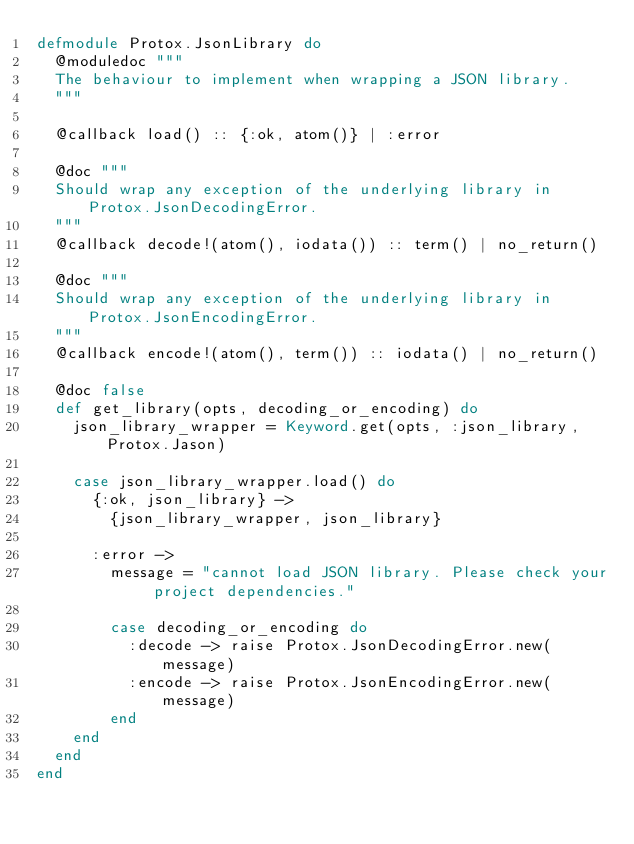Convert code to text. <code><loc_0><loc_0><loc_500><loc_500><_Elixir_>defmodule Protox.JsonLibrary do
  @moduledoc """
  The behaviour to implement when wrapping a JSON library.
  """

  @callback load() :: {:ok, atom()} | :error

  @doc """
  Should wrap any exception of the underlying library in Protox.JsonDecodingError.
  """
  @callback decode!(atom(), iodata()) :: term() | no_return()

  @doc """
  Should wrap any exception of the underlying library in Protox.JsonEncodingError.
  """
  @callback encode!(atom(), term()) :: iodata() | no_return()

  @doc false
  def get_library(opts, decoding_or_encoding) do
    json_library_wrapper = Keyword.get(opts, :json_library, Protox.Jason)

    case json_library_wrapper.load() do
      {:ok, json_library} ->
        {json_library_wrapper, json_library}

      :error ->
        message = "cannot load JSON library. Please check your project dependencies."

        case decoding_or_encoding do
          :decode -> raise Protox.JsonDecodingError.new(message)
          :encode -> raise Protox.JsonEncodingError.new(message)
        end
    end
  end
end
</code> 